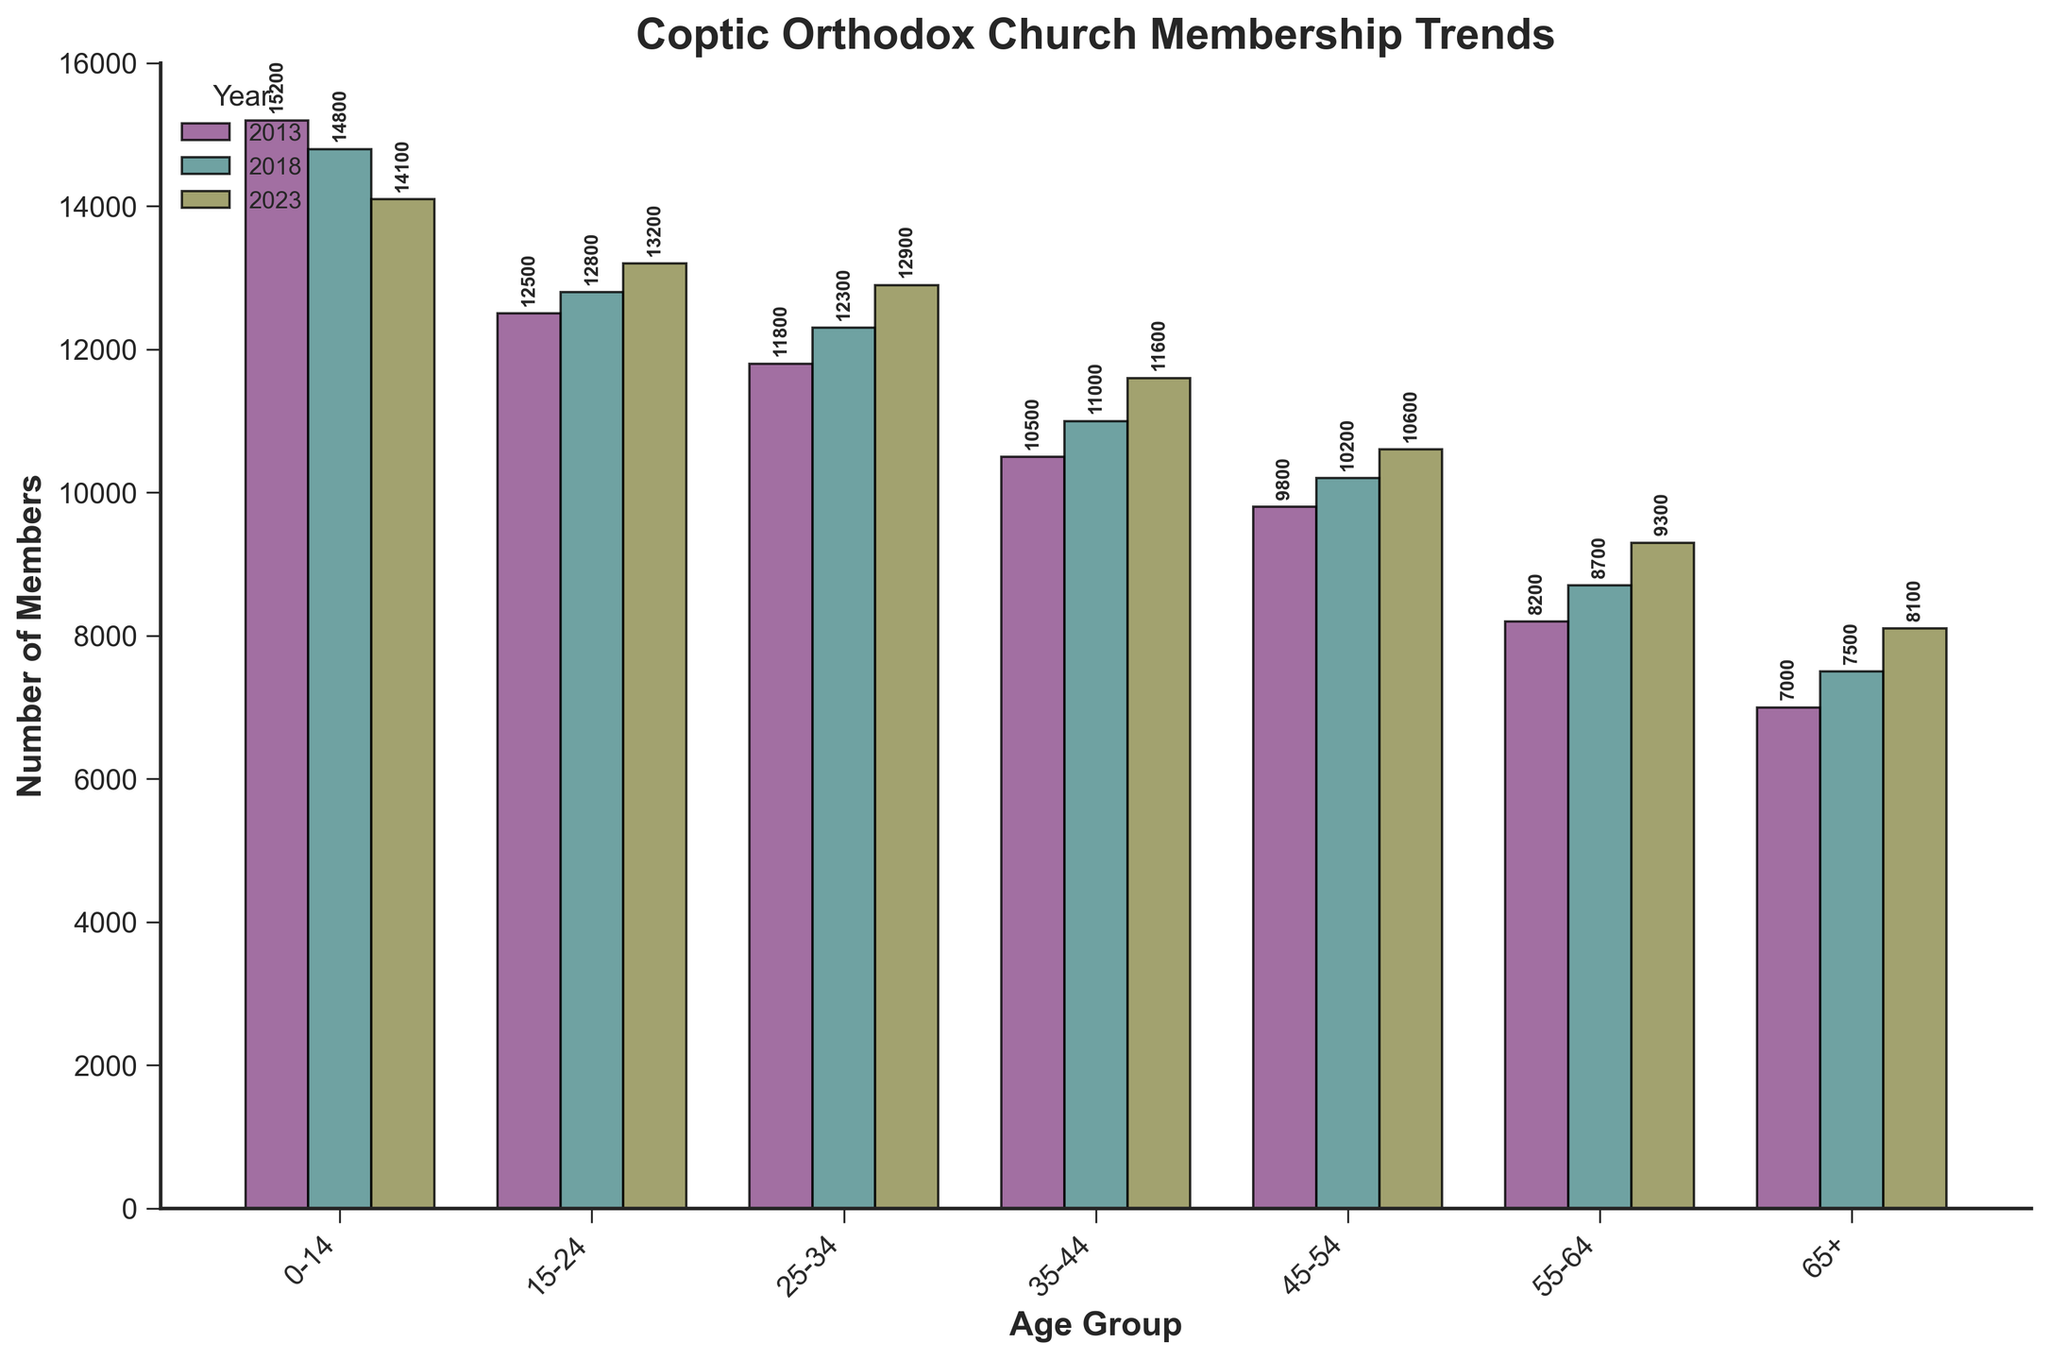Which age group had the highest number of members in 2023? To answer this, look at the heights of the bars corresponding to the year 2023. The age group 0-14 has the highest bar in 2023 with 14,100 members.
Answer: 0-14 How did the number of members in the 35-44 age group change from 2013 to 2023? For this, find the difference in the height of the bars for the 35-44 age group in 2013 and 2023. In 2013, it was 10,500, and in 2023, it was 11,600. Therefore, the change is 11,600 - 10,500 = 1,100.
Answer: Increased by 1,100 Which year had the lowest membership in the 55-64 age group? Find the shortest bar corresponding to the 55-64 age group across all years. The shortest bar is in 2013 with 8,200 members.
Answer: 2013 What is the average membership across all age groups for the year 2018? Sum the heights of all bars for the year 2018 and divide by the number of age groups. The sum is 14,800 + 12,800 + 12,300 + 11,000 + 10,200 + 8,700 + 7,500 = 77,300. The average is 77,300 / 7 = 11,043.
Answer: 11,043 Which age group shows the most consistent membership trend over the decade? To determine consistency, look at the changes in bar heights over the years for each age group. The 65+ group shows consistent growth: 7,000 in 2013, 7,500 in 2018, and 8,100 in 2023.
Answer: 65+ In which age group did the membership increase by the smallest amount from 2013 to 2023? Calculate the membership increase for each age group from 2013 to 2023. The 0-14 group decreased (14,100 - 15,200), but for increases, the 45-54 group had the smallest increase: 10,600 - 9,800 = 800.
Answer: 45-54 Which year had the highest total membership across all age groups? Sum the heights of the bars for each year. For 2013: 15,200 + 12,500 + 11,800 + 10,500 + 9,800 + 8,200 + 7,000 = 75,000. For 2018: 14,800 + 12,800 + 12,300 + 11,000 + 10,200 + 8,700 + 7,500 = 77,300. For 2023: 14,100 + 13,200 + 12,900 + 11,600 + 10,600 + 9,300 + 8,100 = 79,800. The highest total is in 2023 with 79,800 members.
Answer: 2023 Compare the trend of membership in the 0-14 and 15-24 age groups from 2013 to 2023. Look at the heights of the bars for the 0-14 and 15-24 age groups and note changes. The 0-14 group decreased: 15,200 (2013), 14,800 (2018), 14,100 (2023). The 15-24 group increased: 12,500 (2013), 12,800 (2018), 13,200 (2023). Therefore, the 0-14 group decreased while the 15-24 group increased.
Answer: 0-14 decreased, 15-24 increased 